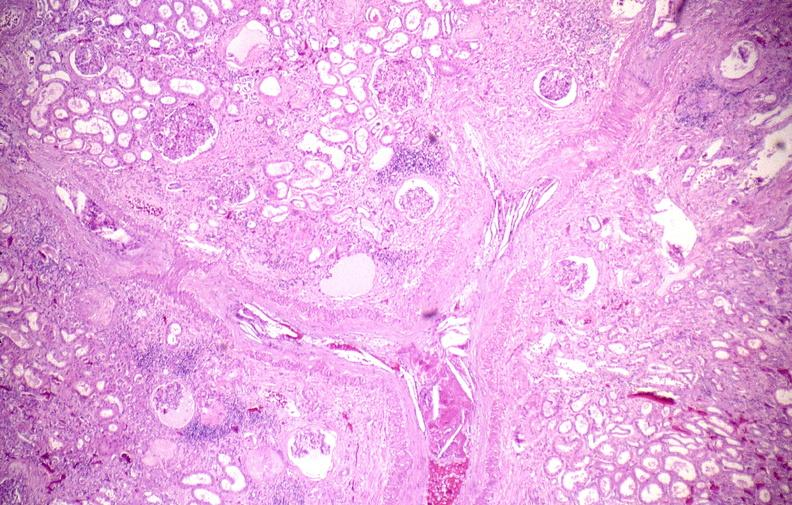where is this?
Answer the question using a single word or phrase. Urinary 